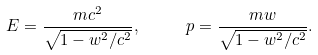<formula> <loc_0><loc_0><loc_500><loc_500>E = \frac { m c ^ { 2 } } { \sqrt { 1 - w ^ { 2 } / c ^ { 2 } } } , \text { \quad } p = \frac { m w } { \sqrt { 1 - w ^ { 2 } / c ^ { 2 } } } .</formula> 